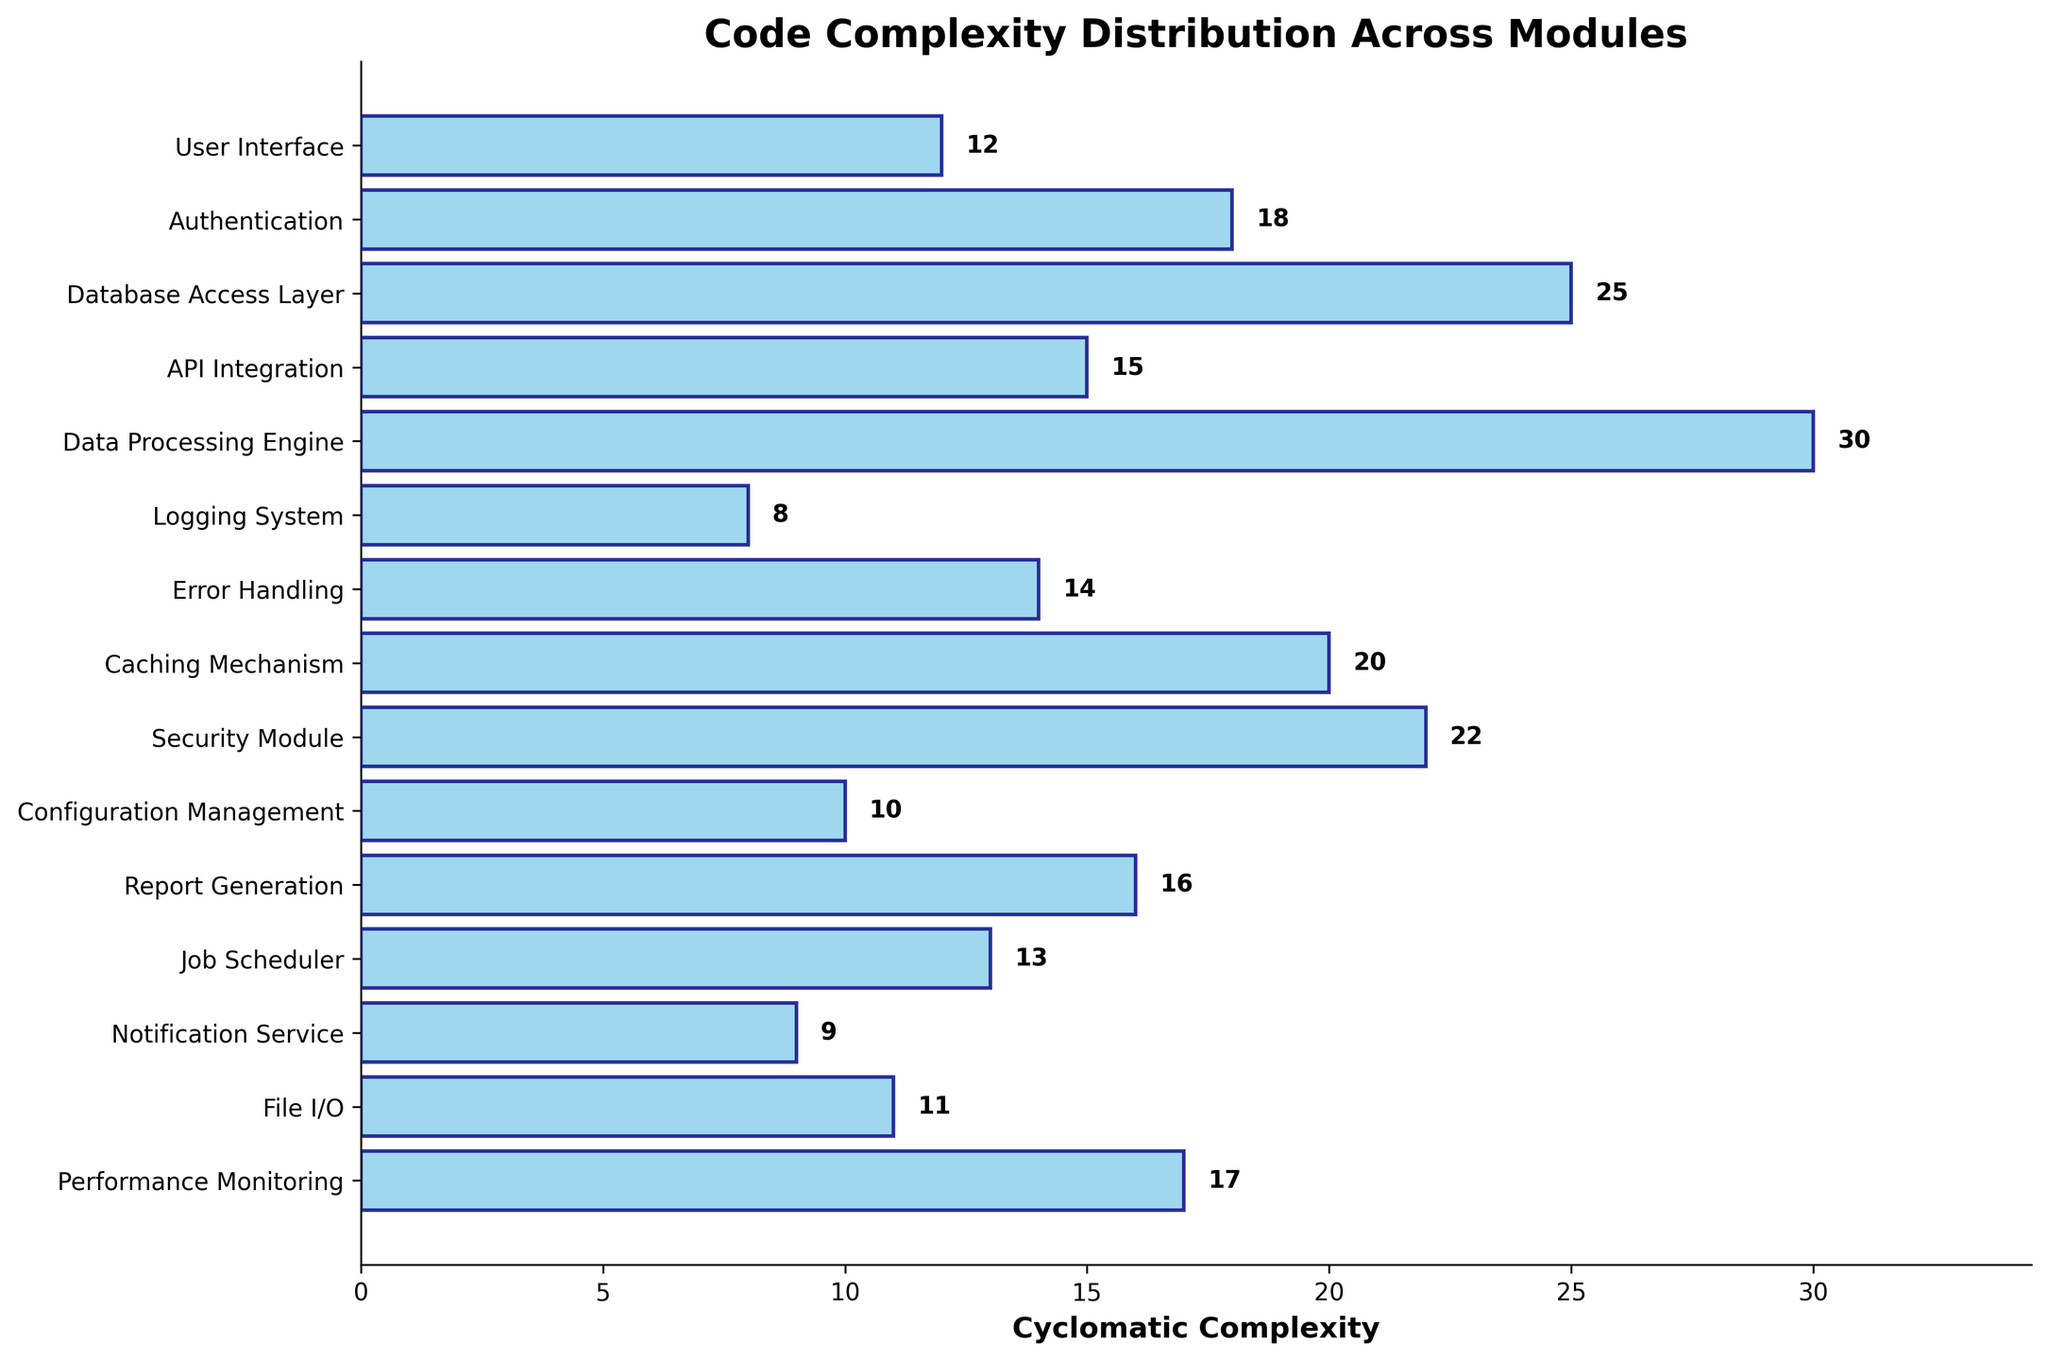How many modules are displayed in the plot? Count the number of items along the y-axis in the figure.
Answer: 15 What module has the highest cyclomatic complexity? Look for the bar that is the longest, as it represents the highest value, and check the corresponding module name on the y-axis.
Answer: Data Processing Engine Compare the cyclomatic complexities of the "Logging System" and "Data Processing Engine". Identify the lengths of the respective bars and compare their values.
Answer: Logging System has 8 and Data Processing Engine has 30 What is the cyclomatic complexity of the "API Integration" module? Find the corresponding bar for "API Integration" and check the value labeled at the end of the bar.
Answer: 15 Which module has a cyclomatic complexity closest to 10? Look for the bar whose value is labeled closest to 10 and check the corresponding module name on the y-axis.
Answer: Configuration Management What is the total cyclomatic complexity of the "Caching Mechanism" and "Security Module"? Sum the cyclomatic complexity values of "Caching Mechanism" (20) and "Security Module" (22).
Answer: 42 Is "Performance Monitoring" more complex than "Notification Service"? Compare the bar lengths of "Performance Monitoring" (17) with "Notification Service" (9).
Answer: Yes What is the median cyclomatic complexity value for the modules? Arrange all the complexity values in ascending order and determine the middle value. Since there are 15 modules, the median is the 8th value in the sorted list.
Answer: 15 Which modules have cyclomatic complexities over 20? Identify the bars that extend beyond the 20 mark and check the corresponding module names.
Answer: Database Access Layer, Caching Mechanism, Security Module, Data Processing Engine By how much does the cyclomatic complexity of "Error Handling" exceed that of "User Interface"? Subtract the cyclomatic complexity of "User Interface" (12) from that of "Error Handling" (14).
Answer: 2 